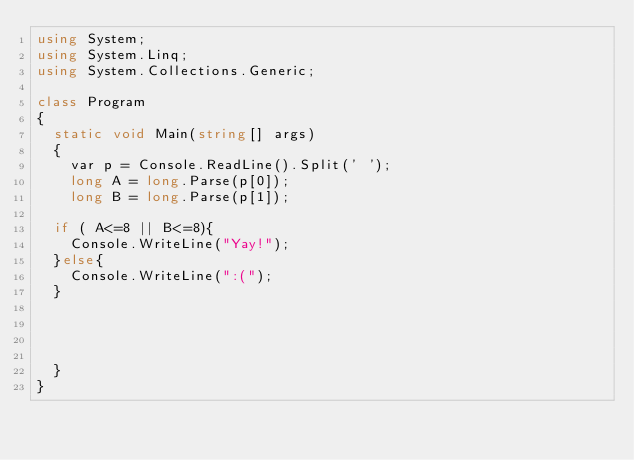Convert code to text. <code><loc_0><loc_0><loc_500><loc_500><_C#_>using System;
using System.Linq;
using System.Collections.Generic;

class Program
{
  static void Main(string[] args)
  {
    var p = Console.ReadLine().Split(' ');
    long A = long.Parse(p[0]);
    long B = long.Parse(p[1]);

  if ( A<=8 || B<=8){
    Console.WriteLine("Yay!");
  }else{
    Console.WriteLine(":(");
  }

    


  }
}
</code> 